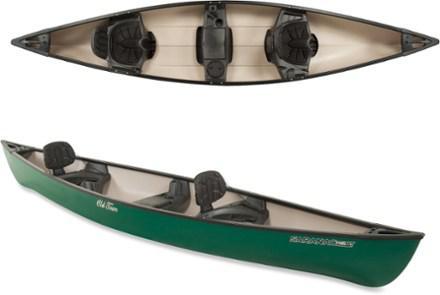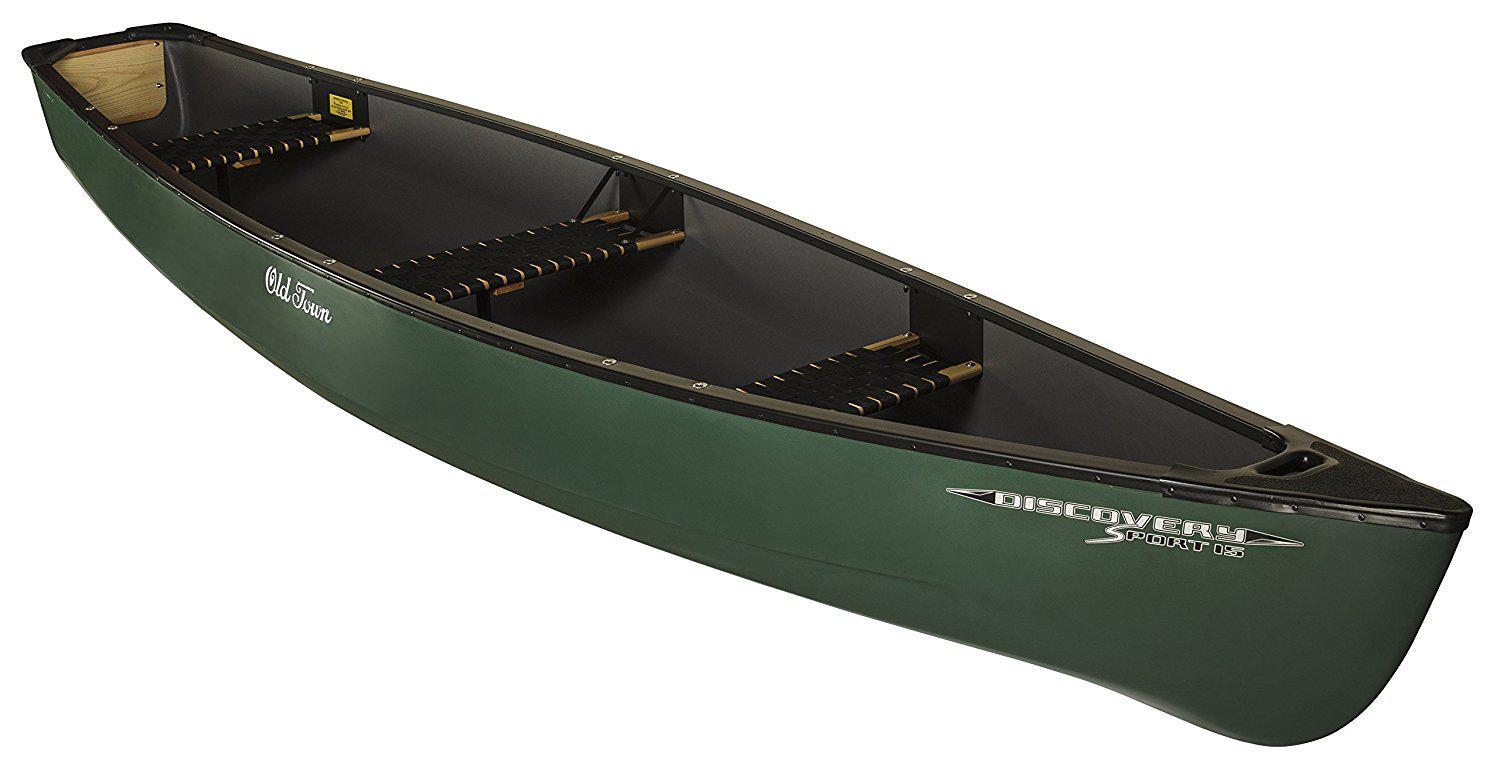The first image is the image on the left, the second image is the image on the right. Analyze the images presented: Is the assertion "One of the boats does not contain seats with backrests." valid? Answer yes or no. Yes. 